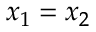Convert formula to latex. <formula><loc_0><loc_0><loc_500><loc_500>x _ { 1 } = x _ { 2 }</formula> 